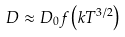<formula> <loc_0><loc_0><loc_500><loc_500>D \approx D _ { 0 } f \left ( k T ^ { 3 / 2 } \right )</formula> 